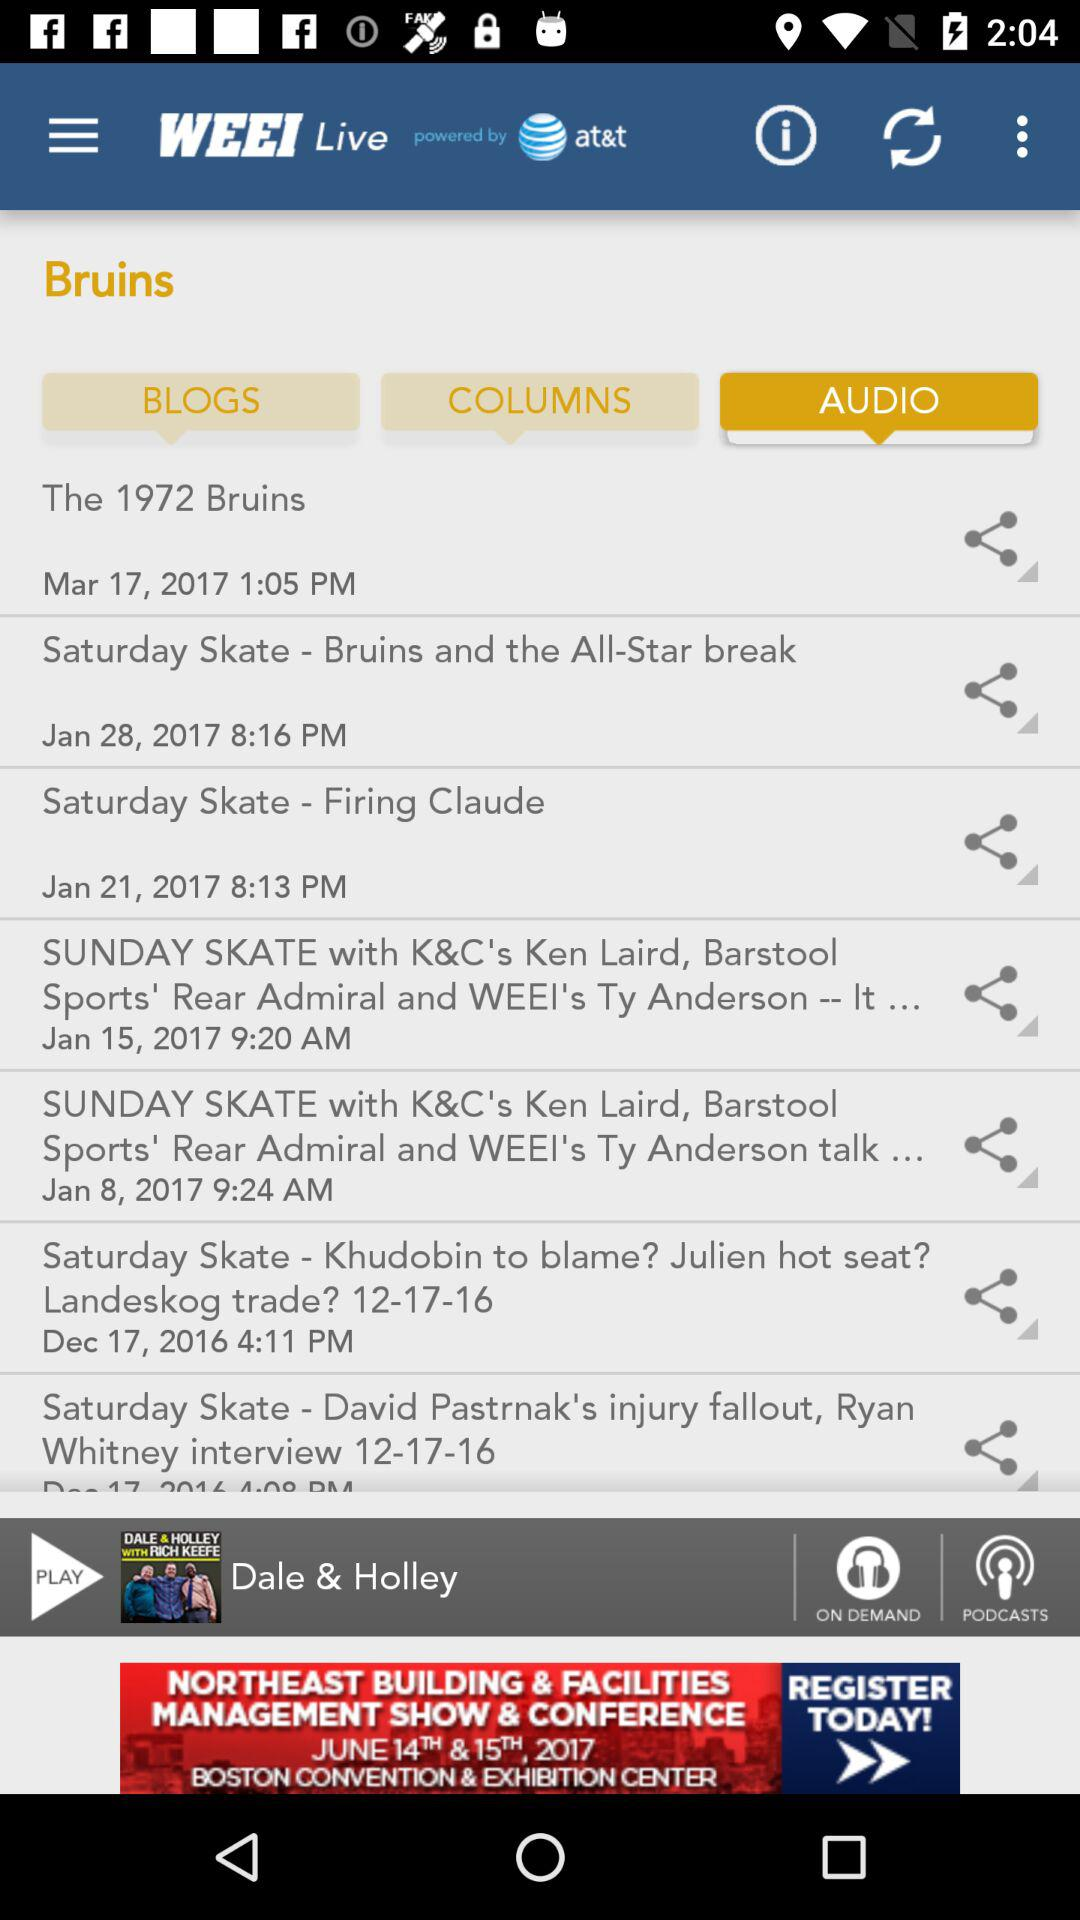What is the time and date of the audio "Saturday Skate - Brunis and the All-Star break"? The time and date of the audio "Saturday Skate - Brunis and the All-Star break" are January 28, 2017 and 8:16 pm respectively. 